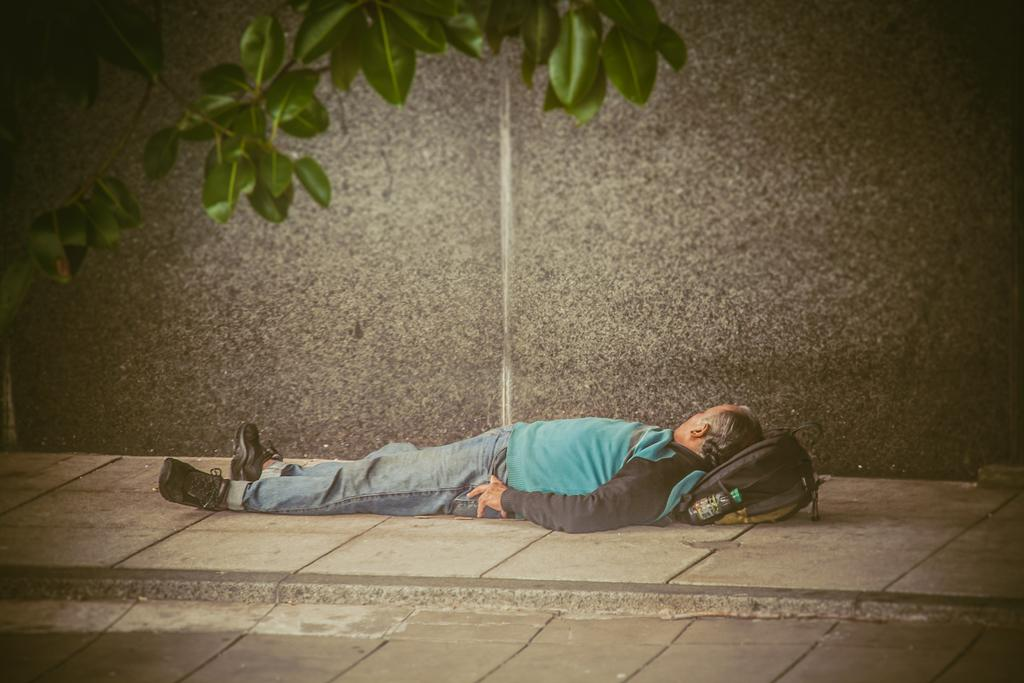What is the person in the image doing? The person is lying on the floor in the image. What is the person using as a pillow? The person is using their backpack as a pillow. What is located beside the person? There is a wall beside the person. What can be seen at the top of the image? Leaves are visible at the top of the image. Is the person driving a car in the image? No, the person is lying on the floor, not driving a car. Can you find the receipt for the person's purchase in the image? There is no mention of a purchase or a receipt in the image. 